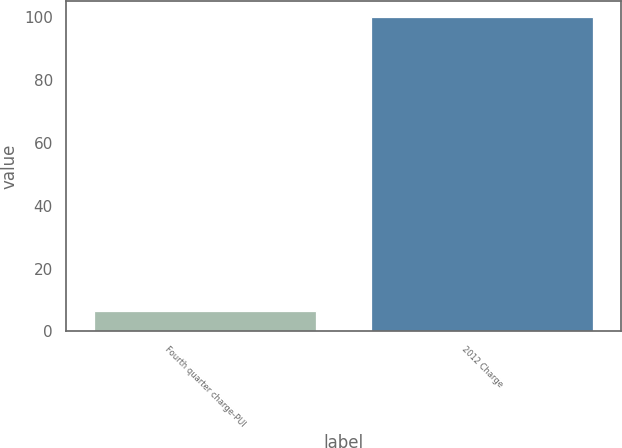<chart> <loc_0><loc_0><loc_500><loc_500><bar_chart><fcel>Fourth quarter charge-PUI<fcel>2012 Charge<nl><fcel>6.5<fcel>100<nl></chart> 